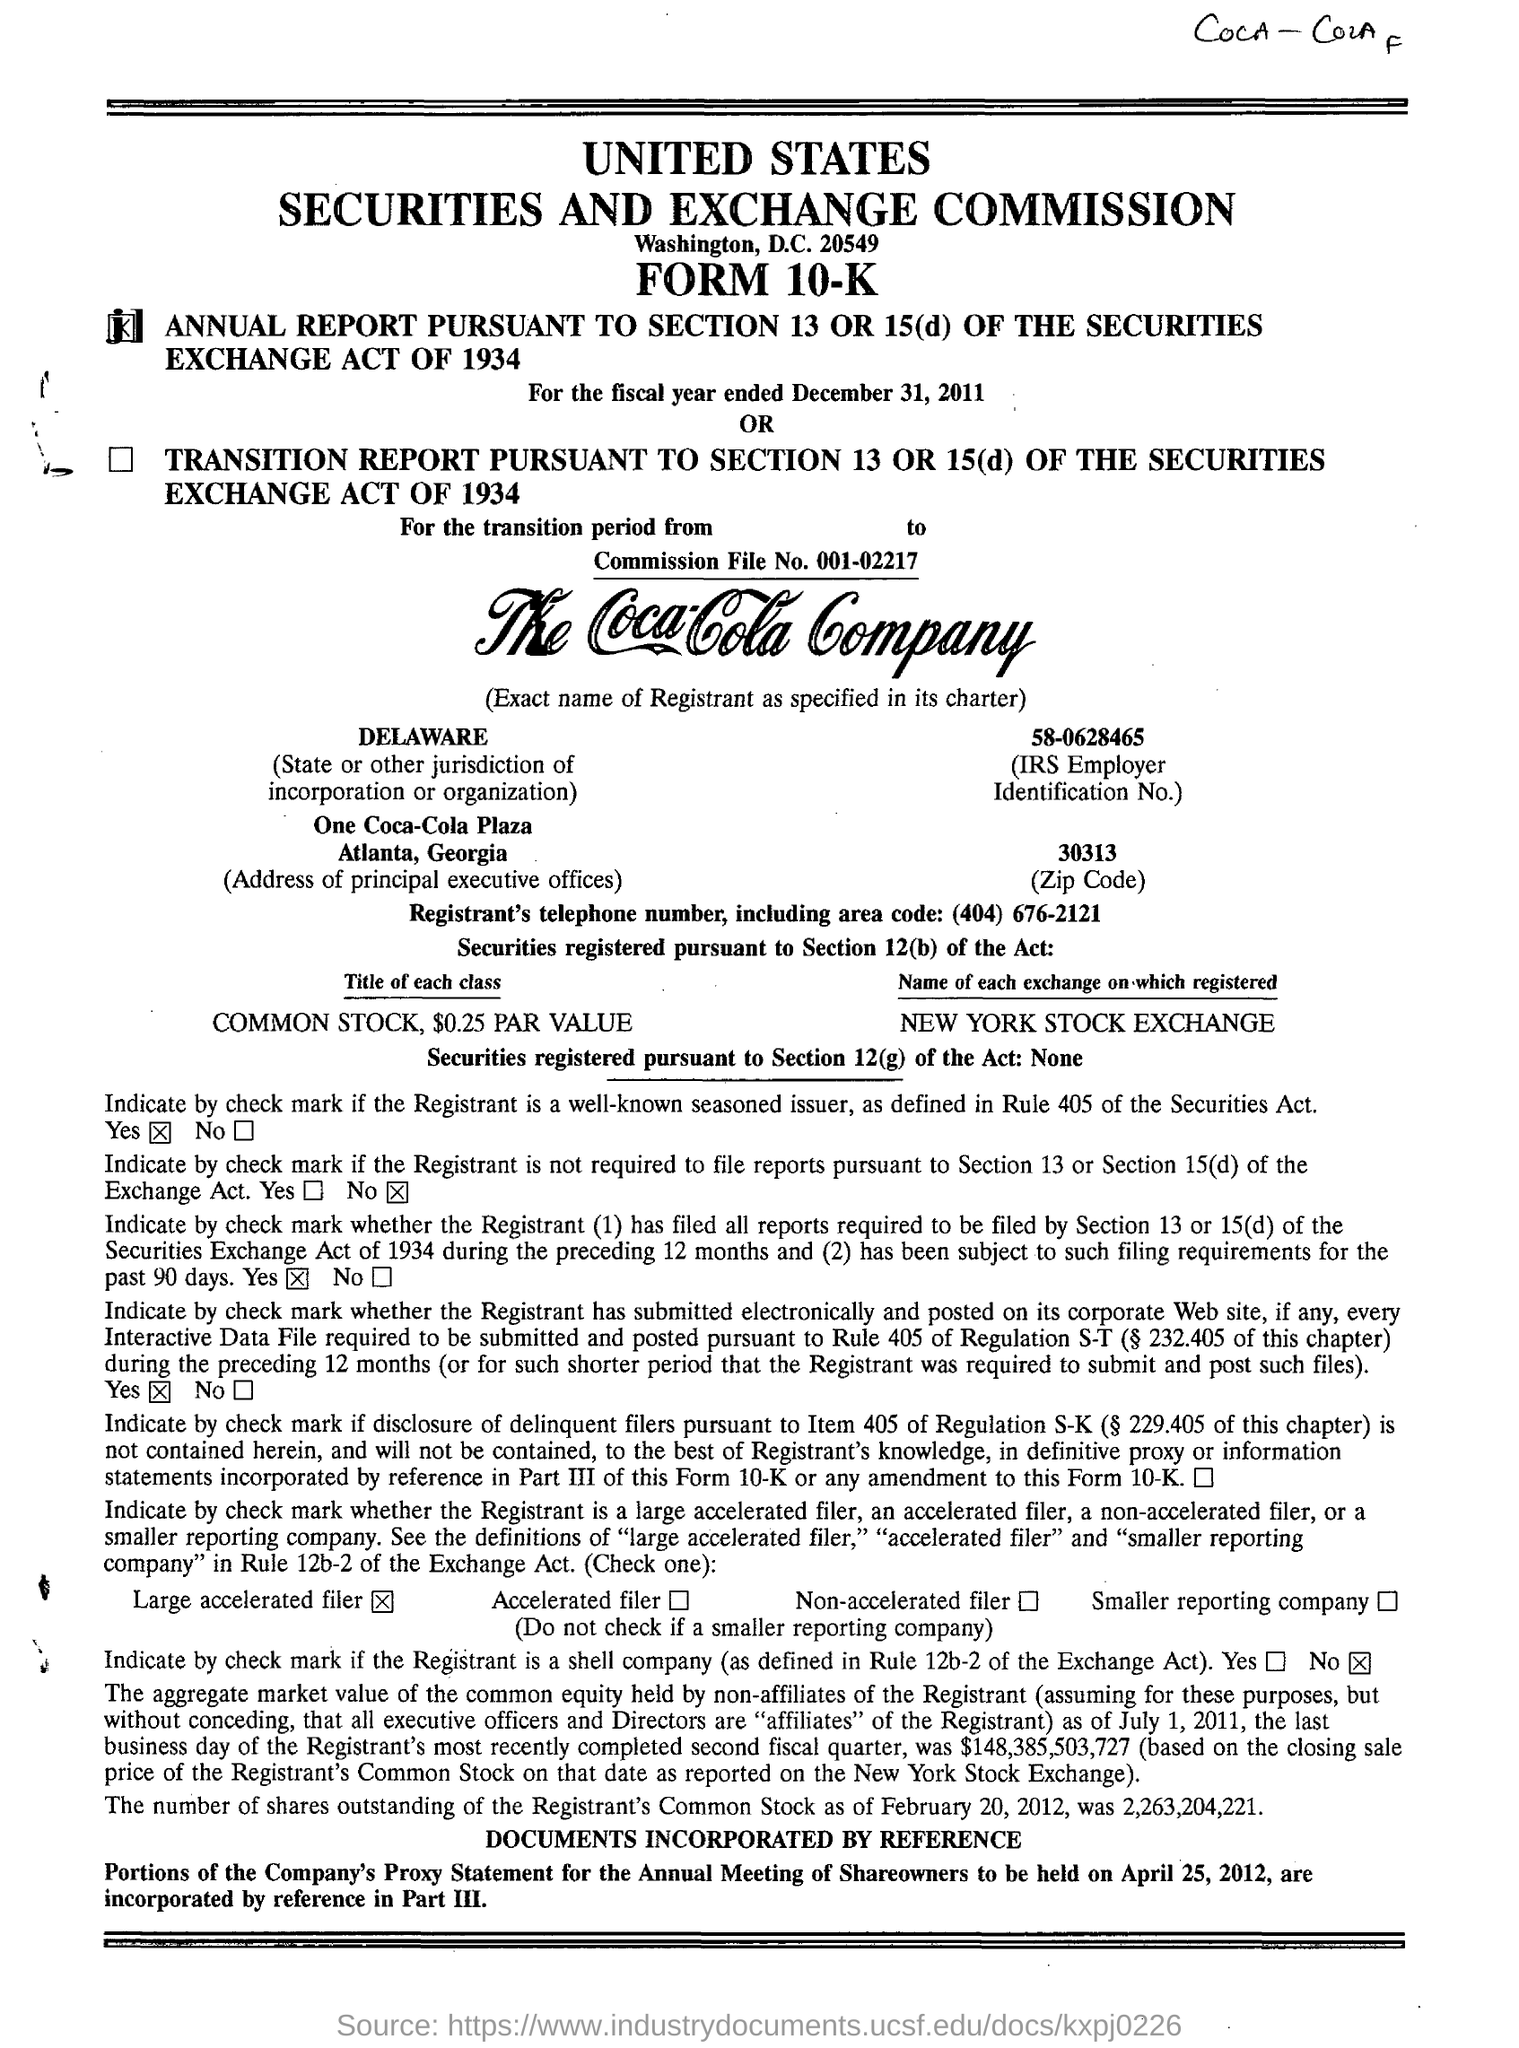What is the Commission File No.?
Provide a succinct answer. 001-02217. What is the name of the place the UNITED STATES SECURITIES AND EXCHANGE COMMISSION is from?
Your response must be concise. Washington, D.C. What is the COMMON STOCK PAR VALUE?
Keep it short and to the point. $0.25. Where is One Coca-Cola Plaza located?
Make the answer very short. Atlanta, georgia. 